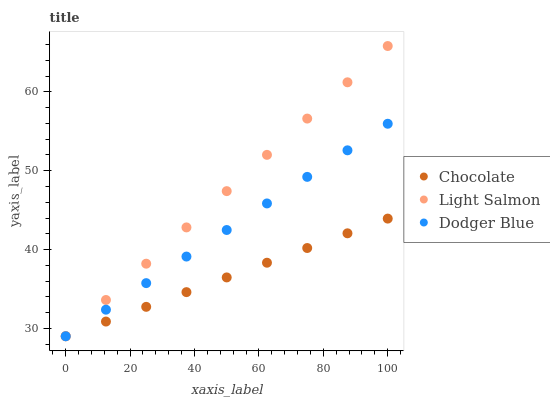Does Chocolate have the minimum area under the curve?
Answer yes or no. Yes. Does Light Salmon have the maximum area under the curve?
Answer yes or no. Yes. Does Dodger Blue have the minimum area under the curve?
Answer yes or no. No. Does Dodger Blue have the maximum area under the curve?
Answer yes or no. No. Is Chocolate the smoothest?
Answer yes or no. Yes. Is Dodger Blue the roughest?
Answer yes or no. Yes. Is Dodger Blue the smoothest?
Answer yes or no. No. Is Chocolate the roughest?
Answer yes or no. No. Does Light Salmon have the lowest value?
Answer yes or no. Yes. Does Light Salmon have the highest value?
Answer yes or no. Yes. Does Dodger Blue have the highest value?
Answer yes or no. No. Does Chocolate intersect Dodger Blue?
Answer yes or no. Yes. Is Chocolate less than Dodger Blue?
Answer yes or no. No. Is Chocolate greater than Dodger Blue?
Answer yes or no. No. 